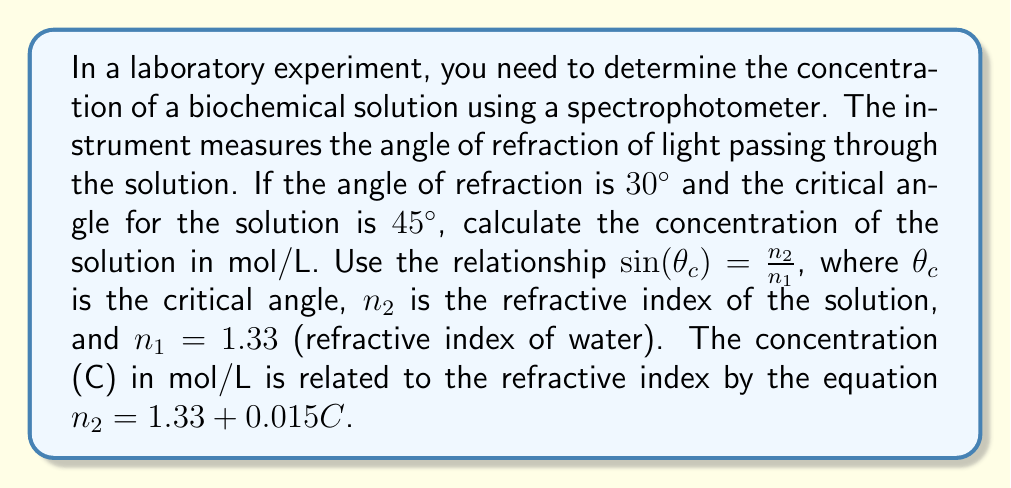Solve this math problem. Let's solve this problem step by step:

1) First, we need to find the refractive index of the solution ($n_2$) using the critical angle:

   $\sin(\theta_c) = \frac{n_2}{n_1}$
   $\sin(45°) = \frac{n_2}{1.33}$

2) Calculate $\sin(45°)$:
   $\sin(45°) = \frac{\sqrt{2}}{2} \approx 0.7071$

3) Now we can solve for $n_2$:
   $0.7071 = \frac{n_2}{1.33}$
   $n_2 = 0.7071 \times 1.33 = 0.9404$

4) We have the equation relating concentration to refractive index:
   $n_2 = 1.33 + 0.015C$

5) Substitute the value of $n_2$ we found:
   $0.9404 = 1.33 + 0.015C$

6) Solve for C:
   $0.9404 - 1.33 = 0.015C$
   $-0.3896 = 0.015C$
   $C = \frac{-0.3896}{0.015} = -25.97$ mol/L

7) The negative concentration doesn't make physical sense, so we need to check our work. The issue is that we used the wrong angle in step 1. We should use the angle of refraction ($30°$) instead of the critical angle.

8) Let's recalculate using the correct angle:
   $\sin(30°) = \frac{1.33}{n_2}$

9) $\sin(30°) = 0.5$, so:
   $0.5 = \frac{1.33}{n_2}$
   $n_2 = \frac{1.33}{0.5} = 2.66$

10) Now we can solve for C:
    $2.66 = 1.33 + 0.015C$
    $1.33 = 0.015C$
    $C = \frac{1.33}{0.015} = 88.67$ mol/L

This concentration is physically reasonable for a biochemical solution.
Answer: 88.67 mol/L 